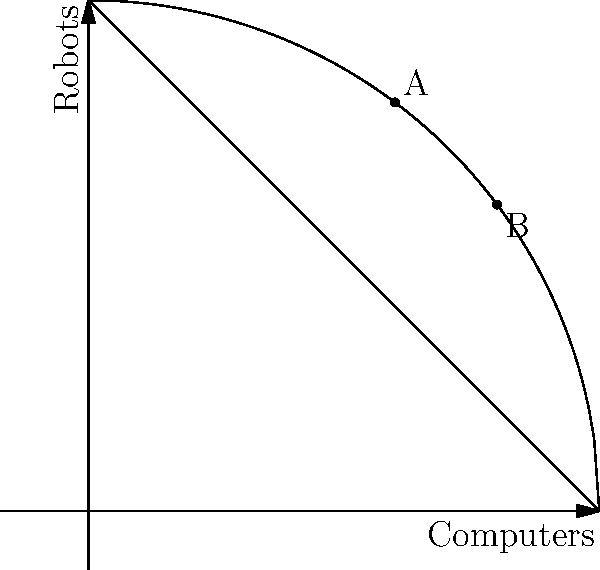The production possibilities frontier (PPF) for a company producing computers and robots is shown above. Point A represents the current production allocation, while point B represents a potential alternative. If the company decides to move from point A to point B, what economic concept does this illustrate, and how does it affect the production of computers and robots? To answer this question, let's analyze the graph and the movement from point A to point B:

1. Identify the current and potential production points:
   - Point A: (6 computers, 8 robots)
   - Point B: (8 computers, 6 robots)

2. Observe the change in production:
   - Computers: Increase from 6 to 8 (gain of 2)
   - Robots: Decrease from 8 to 6 (loss of 2)

3. Recognize the economic concept:
   This movement along the PPF illustrates the concept of opportunity cost. The company is reallocating resources to produce more of one good (computers) at the expense of producing less of another good (robots).

4. Calculate the opportunity cost:
   The opportunity cost of producing 2 additional computers is 2 robots.

5. Interpret the trade-off:
   To increase computer production by 2 units, the company must decrease robot production by 2 units. This showcases the fundamental economic principle of scarcity and the need to make trade-offs in resource allocation.

6. Efficiency consideration:
   Both points A and B lie on the PPF curve, indicating that the company is operating at maximum efficiency in both scenarios. The choice between A and B depends on market demands and the company's strategic goals.
Answer: Opportunity cost: 2 robots for 2 computers 